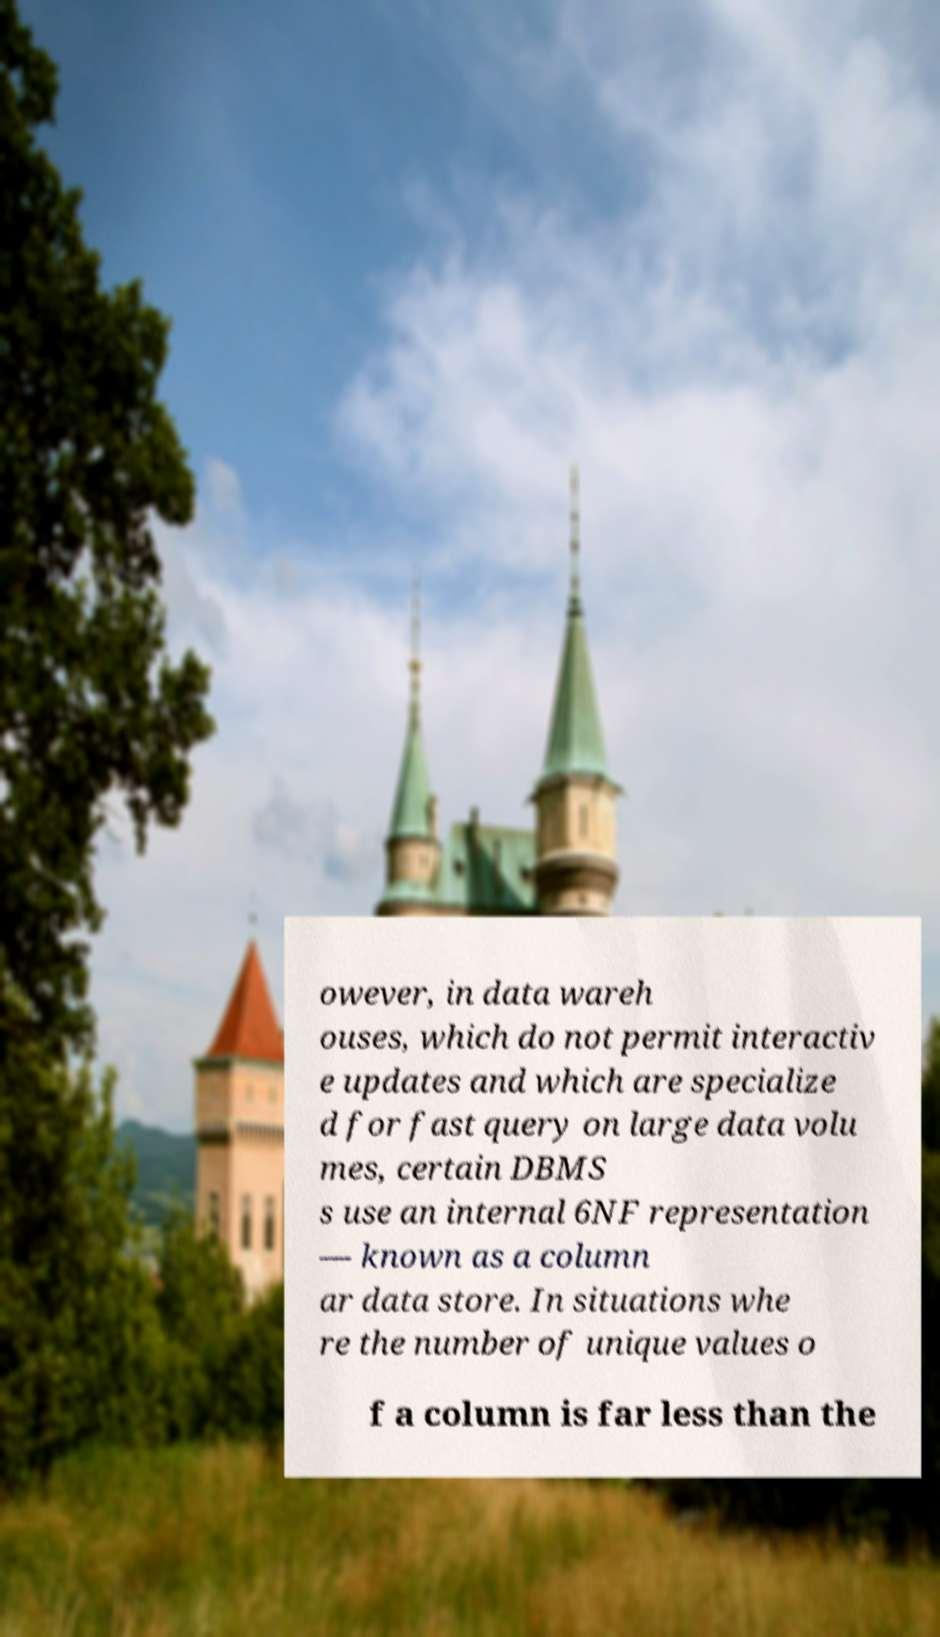Please identify and transcribe the text found in this image. owever, in data wareh ouses, which do not permit interactiv e updates and which are specialize d for fast query on large data volu mes, certain DBMS s use an internal 6NF representation — known as a column ar data store. In situations whe re the number of unique values o f a column is far less than the 